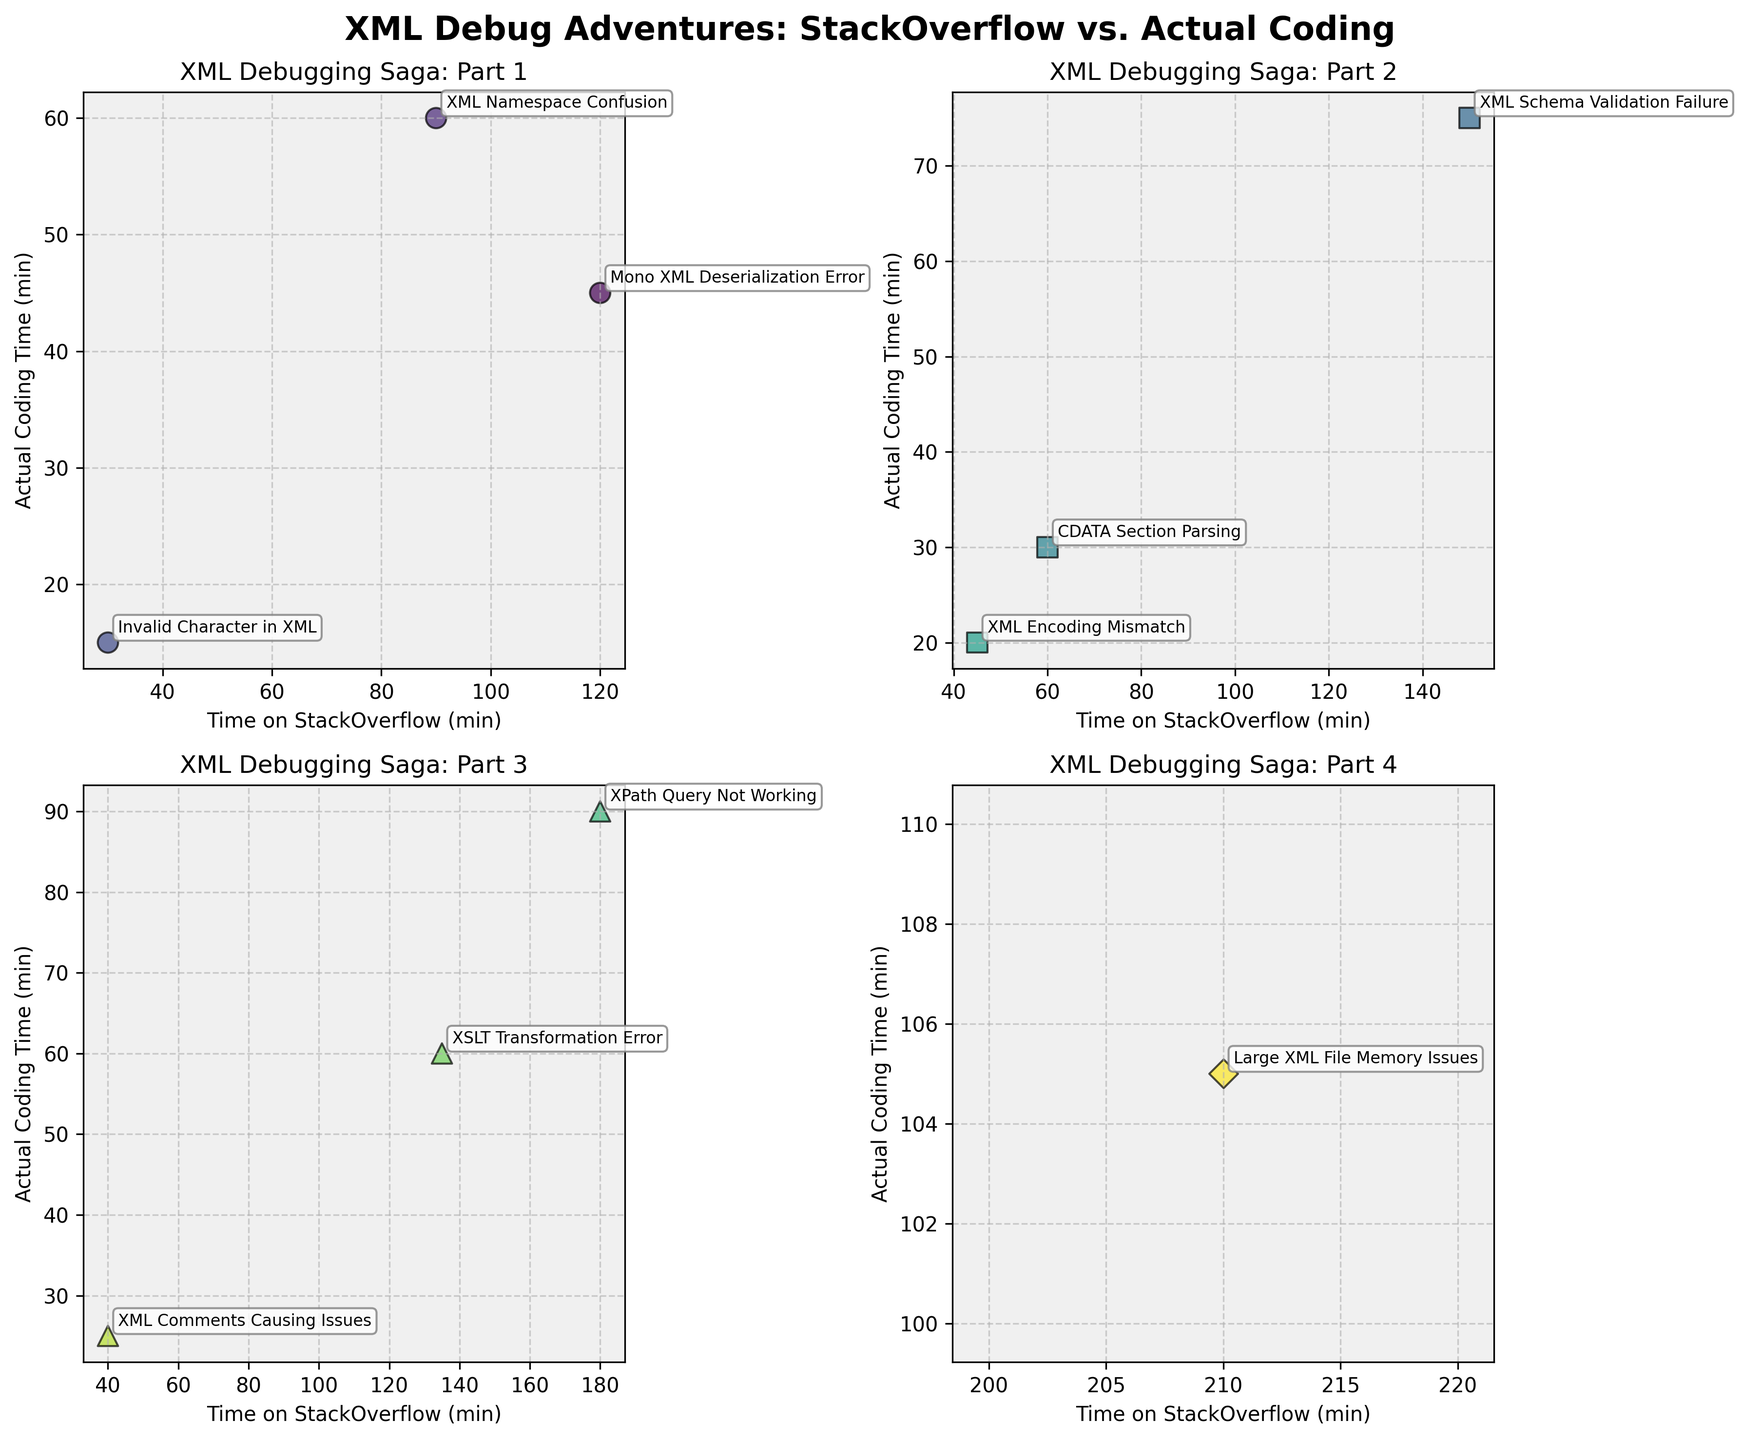What is the title of the figure? The title is displayed at the top of the figure, often providing a summary of the content shown. Here, it reads "XML Debug Adventures: StackOverflow vs. Actual Coding".
Answer: XML Debug Adventures: StackOverflow vs. Actual Coding How many subplots are there in the figure? The figure is divided into a grid of 2x2 subplots, which totals to 2 rows and 2 columns of subplots (4 in total).
Answer: 4 In which subplot is the "XPath Query Not Working" issue located? The issue "XPath Query Not Working" is found in the third set of three data points, so it should be in the third subplot. Since the subplots are arranged in a 2x2 grid, this is located in the subplot at the bottom left.
Answer: Bottom-left Which issue had the highest time spent on StackOverflow? By reviewing the scatter plots, the point with the highest x-coordinate represents the highest time spent on StackOverflow. The issue with the highest x-coordinate is "Large XML File Memory Issues", spending 210 minutes.
Answer: Large XML File Memory Issues Compare the time spent coding for "CDATA Section Parsing" and "XML Comments Causing Issues". Which one had more coding time? Locate the data points for both issues. "CDATA Section Parsing" had 30 minutes of coding time, whereas "XML Comments Causing Issues" had 25 minutes. 30 is greater than 25.
Answer: CDATA Section Parsing What's the range of time spent on StackOverflow in the first subplot? Identify the minimum and maximum values on the x-axis in the first subplot. The range is from the smallest value (30) to the highest value (120). Subtract to get the range: 120 - 30 = 90.
Answer: 90 minutes Which subplot shows issues with the most balanced time spent on StackOverflow and coding? Balanced time means the x and y coordinates are close. The subplot where points lie closest to the x=y line indicates balanced time. The bottom-right subplot shows data points that are relatively closer to this balance.
Answer: Bottom-right On average, do issues in the second subplot (top-right) spend more time on StackOverflow or coding? Calculate the average for each axis in the top-right subplot. Sum the times for StackOverflow (90 + 30 + 150)/3 and coding (60 + 15 + 75)/3: 270/3 = 90 vs. 150/3 = 50. 90 (StackOverflow) is greater than 50 (coding).
Answer: StackOverflow Which issues have exactly double the coding time compared to the time spent on StackOverflow? Double the time coding would imply coding time is twice the StackOverflow time (coding = 2 * StackOverflow). Only one such pair exists: "Large XML File Memory Issues" with 210 (StackOverflow) and 105 (coding).
Answer: Large XML File Memory Issues What is the combined time spent on coding for "XML Namespace Confusion" and "XML Encoding Mismatch"? Look at the coding times for both issues: 60 (XML Namespace Confusion) and 20 (XML Encoding Mismatch). Add them together to get the total: 60 + 20 = 80.
Answer: 80 minutes 